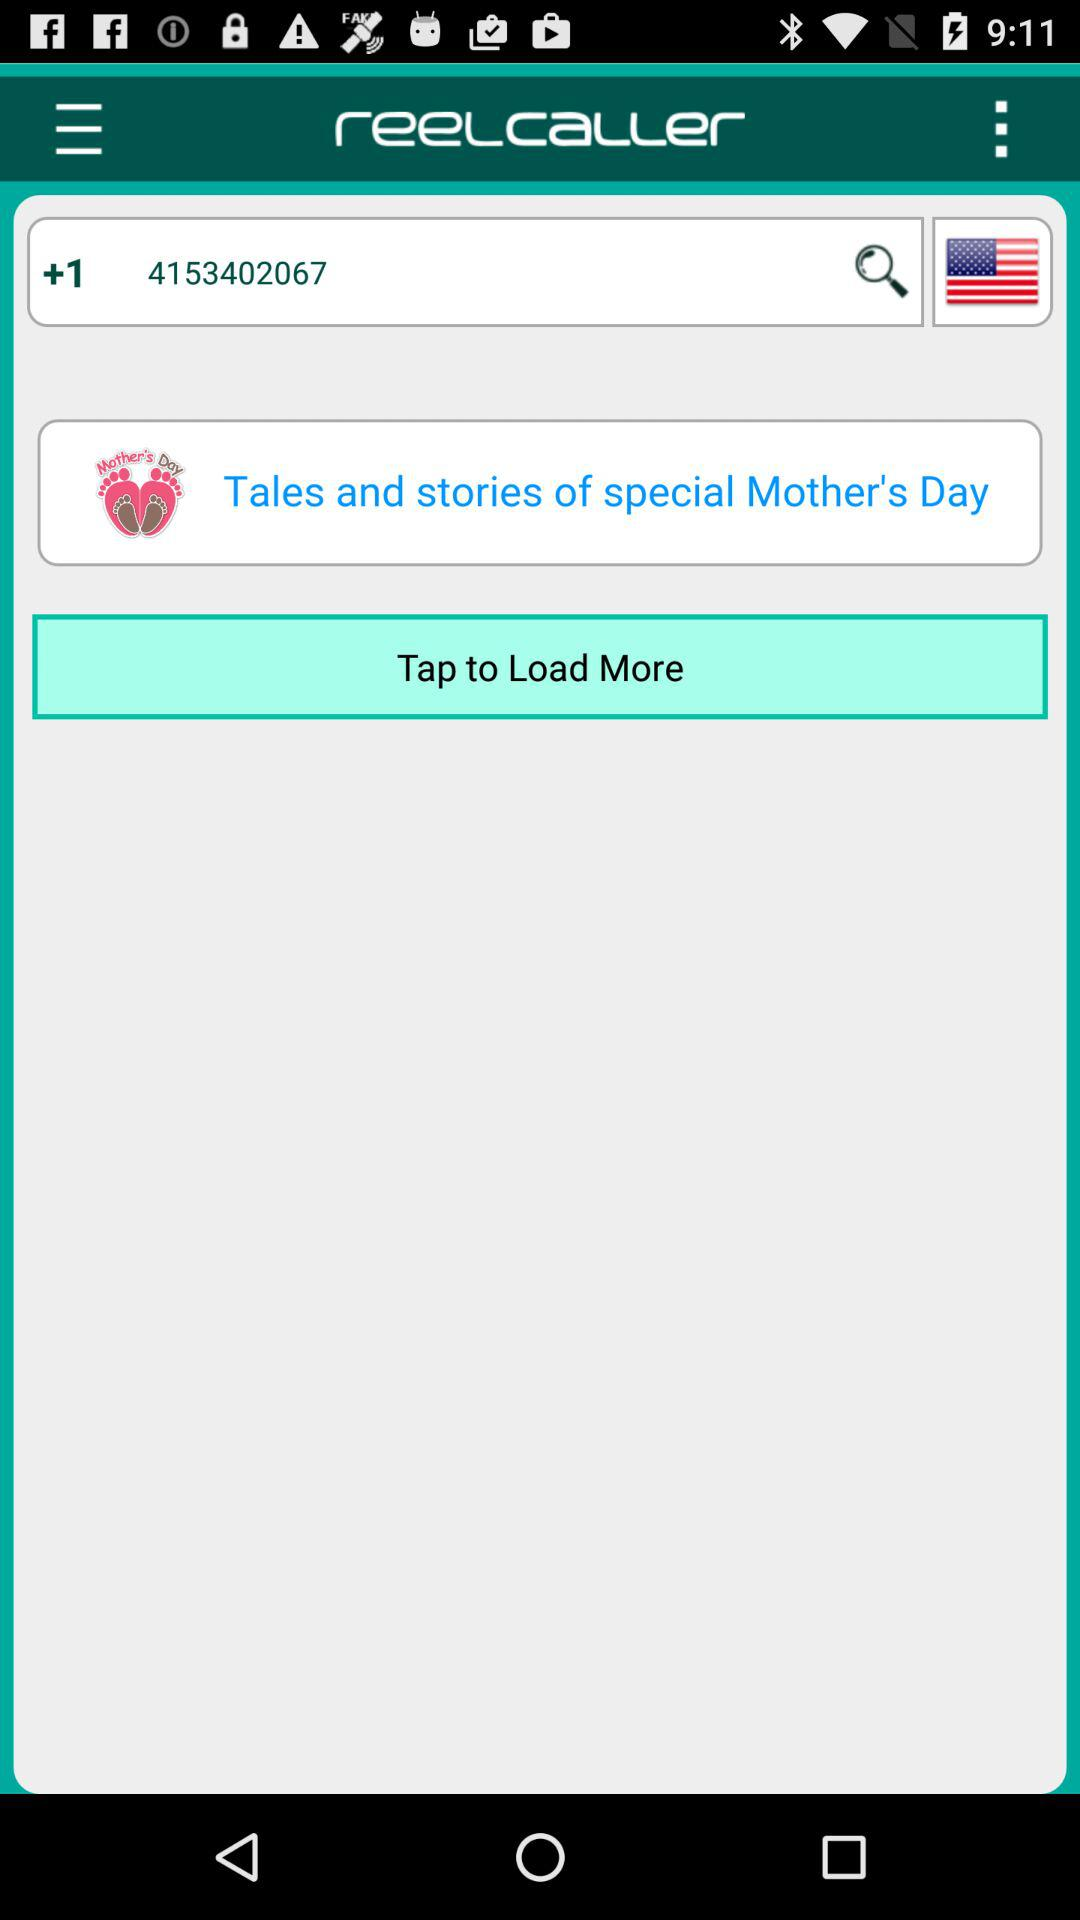What is the mentioned phone number? The mentioned phone number is +1 4153402067. 